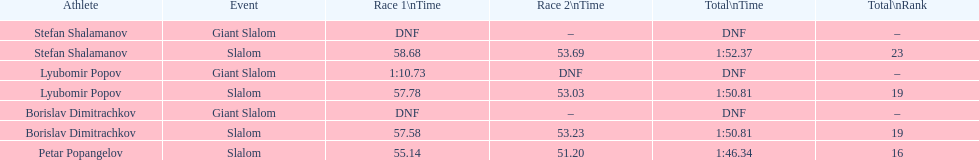Who was the other athlete who tied in rank with lyubomir popov? Borislav Dimitrachkov. 